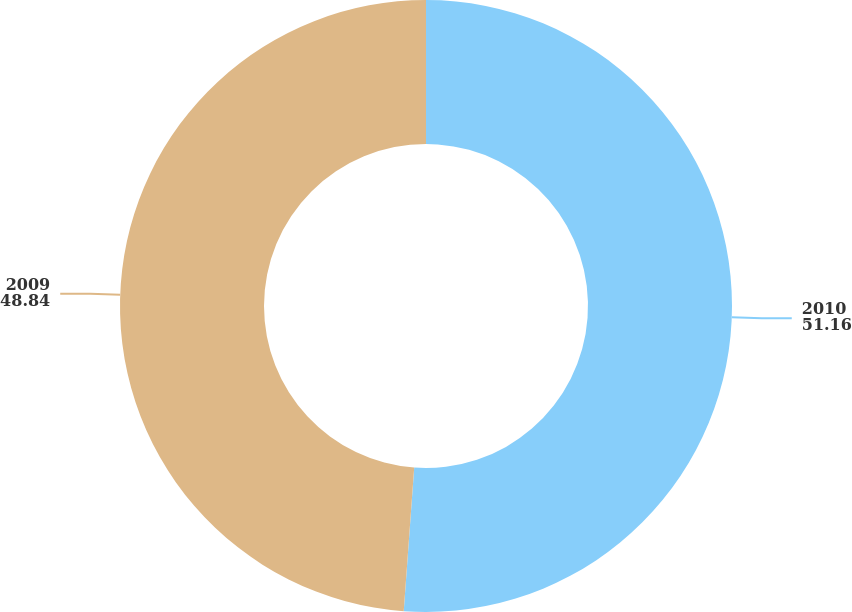Convert chart to OTSL. <chart><loc_0><loc_0><loc_500><loc_500><pie_chart><fcel>2010<fcel>2009<nl><fcel>51.16%<fcel>48.84%<nl></chart> 